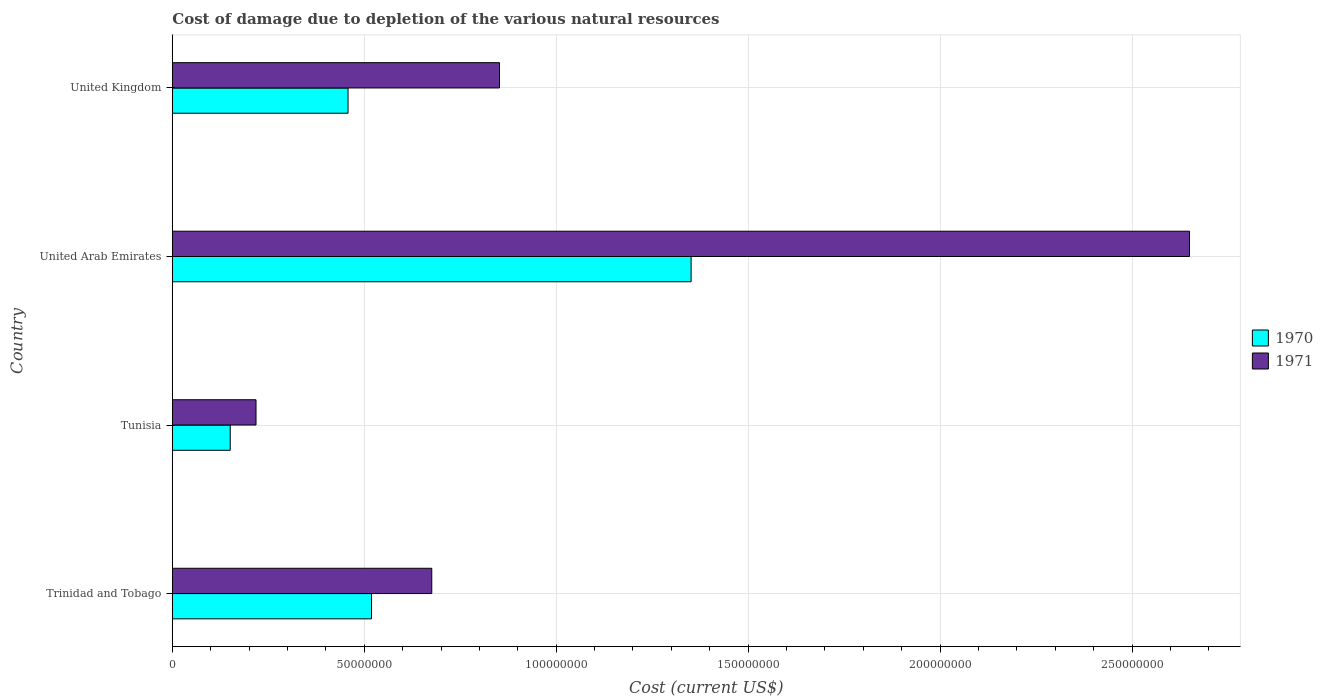How many groups of bars are there?
Make the answer very short. 4. Are the number of bars per tick equal to the number of legend labels?
Your response must be concise. Yes. How many bars are there on the 1st tick from the bottom?
Your response must be concise. 2. What is the cost of damage caused due to the depletion of various natural resources in 1971 in Trinidad and Tobago?
Provide a short and direct response. 6.76e+07. Across all countries, what is the maximum cost of damage caused due to the depletion of various natural resources in 1970?
Make the answer very short. 1.35e+08. Across all countries, what is the minimum cost of damage caused due to the depletion of various natural resources in 1971?
Offer a very short reply. 2.18e+07. In which country was the cost of damage caused due to the depletion of various natural resources in 1971 maximum?
Offer a terse response. United Arab Emirates. In which country was the cost of damage caused due to the depletion of various natural resources in 1971 minimum?
Offer a terse response. Tunisia. What is the total cost of damage caused due to the depletion of various natural resources in 1970 in the graph?
Your answer should be compact. 2.48e+08. What is the difference between the cost of damage caused due to the depletion of various natural resources in 1970 in Tunisia and that in United Arab Emirates?
Your answer should be compact. -1.20e+08. What is the difference between the cost of damage caused due to the depletion of various natural resources in 1971 in United Arab Emirates and the cost of damage caused due to the depletion of various natural resources in 1970 in United Kingdom?
Offer a very short reply. 2.19e+08. What is the average cost of damage caused due to the depletion of various natural resources in 1970 per country?
Offer a very short reply. 6.20e+07. What is the difference between the cost of damage caused due to the depletion of various natural resources in 1970 and cost of damage caused due to the depletion of various natural resources in 1971 in Trinidad and Tobago?
Give a very brief answer. -1.57e+07. In how many countries, is the cost of damage caused due to the depletion of various natural resources in 1971 greater than 130000000 US$?
Keep it short and to the point. 1. What is the ratio of the cost of damage caused due to the depletion of various natural resources in 1971 in United Arab Emirates to that in United Kingdom?
Give a very brief answer. 3.11. Is the cost of damage caused due to the depletion of various natural resources in 1970 in United Arab Emirates less than that in United Kingdom?
Your answer should be compact. No. Is the difference between the cost of damage caused due to the depletion of various natural resources in 1970 in Trinidad and Tobago and United Arab Emirates greater than the difference between the cost of damage caused due to the depletion of various natural resources in 1971 in Trinidad and Tobago and United Arab Emirates?
Keep it short and to the point. Yes. What is the difference between the highest and the second highest cost of damage caused due to the depletion of various natural resources in 1971?
Ensure brevity in your answer.  1.80e+08. What is the difference between the highest and the lowest cost of damage caused due to the depletion of various natural resources in 1970?
Offer a very short reply. 1.20e+08. What does the 1st bar from the bottom in United Arab Emirates represents?
Offer a very short reply. 1970. How many bars are there?
Provide a succinct answer. 8. Are all the bars in the graph horizontal?
Your answer should be compact. Yes. How many countries are there in the graph?
Provide a short and direct response. 4. Does the graph contain any zero values?
Give a very brief answer. No. Does the graph contain grids?
Your answer should be very brief. Yes. Where does the legend appear in the graph?
Offer a very short reply. Center right. How many legend labels are there?
Provide a succinct answer. 2. What is the title of the graph?
Provide a succinct answer. Cost of damage due to depletion of the various natural resources. What is the label or title of the X-axis?
Keep it short and to the point. Cost (current US$). What is the Cost (current US$) in 1970 in Trinidad and Tobago?
Provide a succinct answer. 5.19e+07. What is the Cost (current US$) in 1971 in Trinidad and Tobago?
Ensure brevity in your answer.  6.76e+07. What is the Cost (current US$) of 1970 in Tunisia?
Provide a short and direct response. 1.51e+07. What is the Cost (current US$) of 1971 in Tunisia?
Keep it short and to the point. 2.18e+07. What is the Cost (current US$) in 1970 in United Arab Emirates?
Your answer should be very brief. 1.35e+08. What is the Cost (current US$) of 1971 in United Arab Emirates?
Provide a short and direct response. 2.65e+08. What is the Cost (current US$) in 1970 in United Kingdom?
Your response must be concise. 4.58e+07. What is the Cost (current US$) in 1971 in United Kingdom?
Provide a short and direct response. 8.52e+07. Across all countries, what is the maximum Cost (current US$) of 1970?
Your answer should be compact. 1.35e+08. Across all countries, what is the maximum Cost (current US$) of 1971?
Your answer should be very brief. 2.65e+08. Across all countries, what is the minimum Cost (current US$) in 1970?
Your response must be concise. 1.51e+07. Across all countries, what is the minimum Cost (current US$) of 1971?
Ensure brevity in your answer.  2.18e+07. What is the total Cost (current US$) of 1970 in the graph?
Provide a short and direct response. 2.48e+08. What is the total Cost (current US$) of 1971 in the graph?
Provide a short and direct response. 4.40e+08. What is the difference between the Cost (current US$) in 1970 in Trinidad and Tobago and that in Tunisia?
Give a very brief answer. 3.68e+07. What is the difference between the Cost (current US$) of 1971 in Trinidad and Tobago and that in Tunisia?
Make the answer very short. 4.58e+07. What is the difference between the Cost (current US$) of 1970 in Trinidad and Tobago and that in United Arab Emirates?
Provide a short and direct response. -8.33e+07. What is the difference between the Cost (current US$) in 1971 in Trinidad and Tobago and that in United Arab Emirates?
Keep it short and to the point. -1.97e+08. What is the difference between the Cost (current US$) in 1970 in Trinidad and Tobago and that in United Kingdom?
Your answer should be compact. 6.11e+06. What is the difference between the Cost (current US$) of 1971 in Trinidad and Tobago and that in United Kingdom?
Your answer should be very brief. -1.76e+07. What is the difference between the Cost (current US$) of 1970 in Tunisia and that in United Arab Emirates?
Ensure brevity in your answer.  -1.20e+08. What is the difference between the Cost (current US$) in 1971 in Tunisia and that in United Arab Emirates?
Ensure brevity in your answer.  -2.43e+08. What is the difference between the Cost (current US$) of 1970 in Tunisia and that in United Kingdom?
Keep it short and to the point. -3.07e+07. What is the difference between the Cost (current US$) of 1971 in Tunisia and that in United Kingdom?
Give a very brief answer. -6.34e+07. What is the difference between the Cost (current US$) in 1970 in United Arab Emirates and that in United Kingdom?
Provide a short and direct response. 8.94e+07. What is the difference between the Cost (current US$) of 1971 in United Arab Emirates and that in United Kingdom?
Provide a succinct answer. 1.80e+08. What is the difference between the Cost (current US$) of 1970 in Trinidad and Tobago and the Cost (current US$) of 1971 in Tunisia?
Keep it short and to the point. 3.01e+07. What is the difference between the Cost (current US$) in 1970 in Trinidad and Tobago and the Cost (current US$) in 1971 in United Arab Emirates?
Make the answer very short. -2.13e+08. What is the difference between the Cost (current US$) in 1970 in Trinidad and Tobago and the Cost (current US$) in 1971 in United Kingdom?
Provide a short and direct response. -3.34e+07. What is the difference between the Cost (current US$) in 1970 in Tunisia and the Cost (current US$) in 1971 in United Arab Emirates?
Your answer should be very brief. -2.50e+08. What is the difference between the Cost (current US$) in 1970 in Tunisia and the Cost (current US$) in 1971 in United Kingdom?
Your answer should be compact. -7.02e+07. What is the difference between the Cost (current US$) in 1970 in United Arab Emirates and the Cost (current US$) in 1971 in United Kingdom?
Give a very brief answer. 4.99e+07. What is the average Cost (current US$) of 1970 per country?
Provide a succinct answer. 6.20e+07. What is the average Cost (current US$) of 1971 per country?
Offer a terse response. 1.10e+08. What is the difference between the Cost (current US$) of 1970 and Cost (current US$) of 1971 in Trinidad and Tobago?
Your answer should be very brief. -1.57e+07. What is the difference between the Cost (current US$) in 1970 and Cost (current US$) in 1971 in Tunisia?
Your answer should be very brief. -6.72e+06. What is the difference between the Cost (current US$) of 1970 and Cost (current US$) of 1971 in United Arab Emirates?
Give a very brief answer. -1.30e+08. What is the difference between the Cost (current US$) of 1970 and Cost (current US$) of 1971 in United Kingdom?
Offer a very short reply. -3.95e+07. What is the ratio of the Cost (current US$) of 1970 in Trinidad and Tobago to that in Tunisia?
Offer a terse response. 3.44. What is the ratio of the Cost (current US$) of 1971 in Trinidad and Tobago to that in Tunisia?
Offer a terse response. 3.1. What is the ratio of the Cost (current US$) in 1970 in Trinidad and Tobago to that in United Arab Emirates?
Offer a terse response. 0.38. What is the ratio of the Cost (current US$) in 1971 in Trinidad and Tobago to that in United Arab Emirates?
Your response must be concise. 0.26. What is the ratio of the Cost (current US$) in 1970 in Trinidad and Tobago to that in United Kingdom?
Your answer should be very brief. 1.13. What is the ratio of the Cost (current US$) in 1971 in Trinidad and Tobago to that in United Kingdom?
Your answer should be compact. 0.79. What is the ratio of the Cost (current US$) in 1970 in Tunisia to that in United Arab Emirates?
Your answer should be very brief. 0.11. What is the ratio of the Cost (current US$) of 1971 in Tunisia to that in United Arab Emirates?
Offer a very short reply. 0.08. What is the ratio of the Cost (current US$) in 1970 in Tunisia to that in United Kingdom?
Your answer should be very brief. 0.33. What is the ratio of the Cost (current US$) of 1971 in Tunisia to that in United Kingdom?
Keep it short and to the point. 0.26. What is the ratio of the Cost (current US$) in 1970 in United Arab Emirates to that in United Kingdom?
Provide a short and direct response. 2.95. What is the ratio of the Cost (current US$) of 1971 in United Arab Emirates to that in United Kingdom?
Offer a terse response. 3.11. What is the difference between the highest and the second highest Cost (current US$) in 1970?
Ensure brevity in your answer.  8.33e+07. What is the difference between the highest and the second highest Cost (current US$) of 1971?
Your answer should be compact. 1.80e+08. What is the difference between the highest and the lowest Cost (current US$) of 1970?
Ensure brevity in your answer.  1.20e+08. What is the difference between the highest and the lowest Cost (current US$) in 1971?
Ensure brevity in your answer.  2.43e+08. 